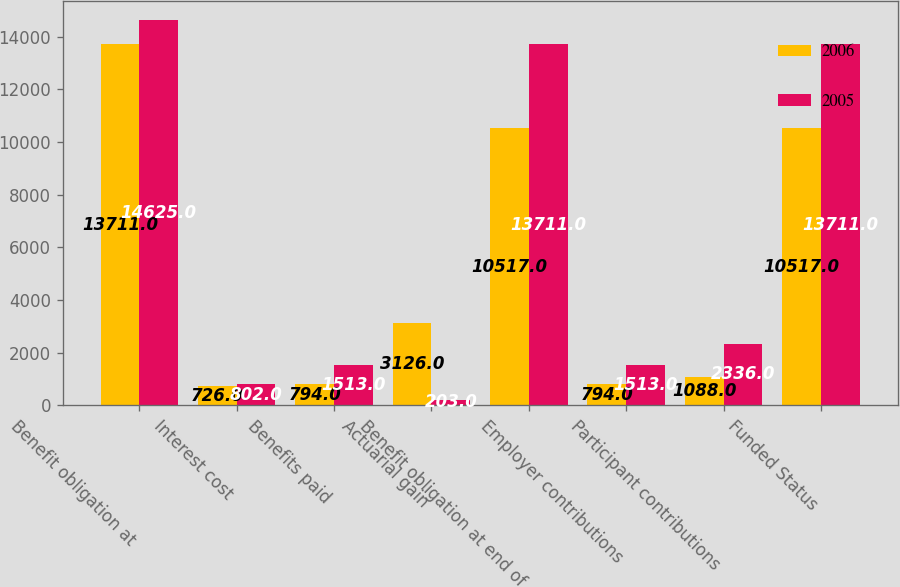Convert chart to OTSL. <chart><loc_0><loc_0><loc_500><loc_500><stacked_bar_chart><ecel><fcel>Benefit obligation at<fcel>Interest cost<fcel>Benefits paid<fcel>Actuarial gain<fcel>Benefit obligation at end of<fcel>Employer contributions<fcel>Participant contributions<fcel>Funded Status<nl><fcel>2006<fcel>13711<fcel>726<fcel>794<fcel>3126<fcel>10517<fcel>794<fcel>1088<fcel>10517<nl><fcel>2005<fcel>14625<fcel>802<fcel>1513<fcel>203<fcel>13711<fcel>1513<fcel>2336<fcel>13711<nl></chart> 